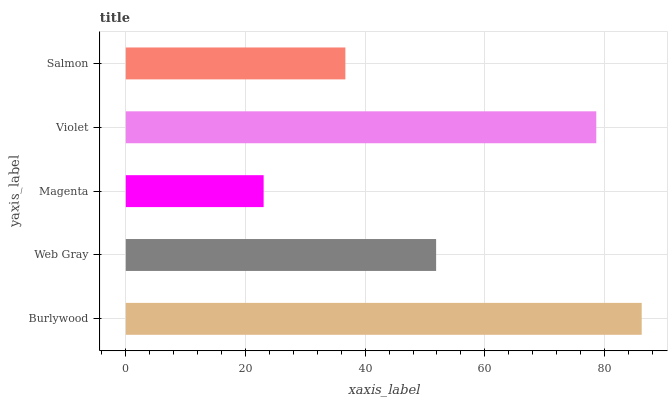Is Magenta the minimum?
Answer yes or no. Yes. Is Burlywood the maximum?
Answer yes or no. Yes. Is Web Gray the minimum?
Answer yes or no. No. Is Web Gray the maximum?
Answer yes or no. No. Is Burlywood greater than Web Gray?
Answer yes or no. Yes. Is Web Gray less than Burlywood?
Answer yes or no. Yes. Is Web Gray greater than Burlywood?
Answer yes or no. No. Is Burlywood less than Web Gray?
Answer yes or no. No. Is Web Gray the high median?
Answer yes or no. Yes. Is Web Gray the low median?
Answer yes or no. Yes. Is Salmon the high median?
Answer yes or no. No. Is Violet the low median?
Answer yes or no. No. 